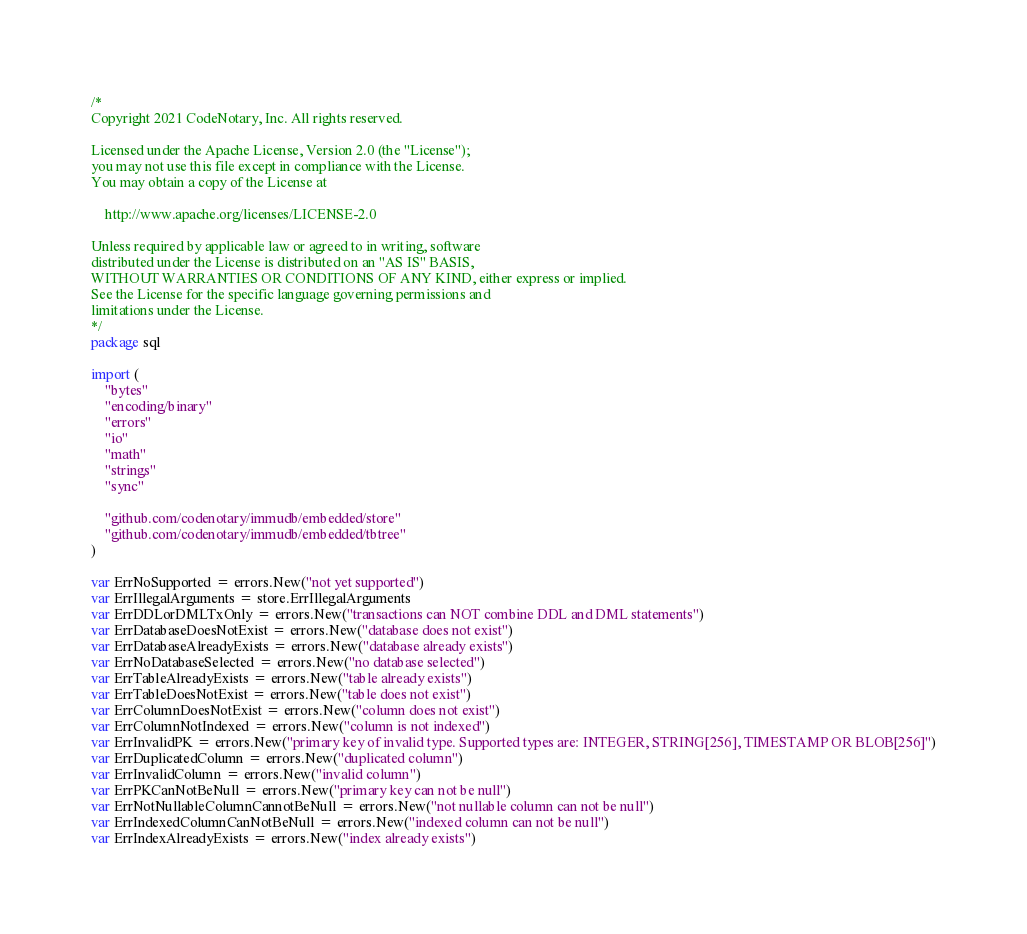<code> <loc_0><loc_0><loc_500><loc_500><_Go_>/*
Copyright 2021 CodeNotary, Inc. All rights reserved.

Licensed under the Apache License, Version 2.0 (the "License");
you may not use this file except in compliance with the License.
You may obtain a copy of the License at

	http://www.apache.org/licenses/LICENSE-2.0

Unless required by applicable law or agreed to in writing, software
distributed under the License is distributed on an "AS IS" BASIS,
WITHOUT WARRANTIES OR CONDITIONS OF ANY KIND, either express or implied.
See the License for the specific language governing permissions and
limitations under the License.
*/
package sql

import (
	"bytes"
	"encoding/binary"
	"errors"
	"io"
	"math"
	"strings"
	"sync"

	"github.com/codenotary/immudb/embedded/store"
	"github.com/codenotary/immudb/embedded/tbtree"
)

var ErrNoSupported = errors.New("not yet supported")
var ErrIllegalArguments = store.ErrIllegalArguments
var ErrDDLorDMLTxOnly = errors.New("transactions can NOT combine DDL and DML statements")
var ErrDatabaseDoesNotExist = errors.New("database does not exist")
var ErrDatabaseAlreadyExists = errors.New("database already exists")
var ErrNoDatabaseSelected = errors.New("no database selected")
var ErrTableAlreadyExists = errors.New("table already exists")
var ErrTableDoesNotExist = errors.New("table does not exist")
var ErrColumnDoesNotExist = errors.New("column does not exist")
var ErrColumnNotIndexed = errors.New("column is not indexed")
var ErrInvalidPK = errors.New("primary key of invalid type. Supported types are: INTEGER, STRING[256], TIMESTAMP OR BLOB[256]")
var ErrDuplicatedColumn = errors.New("duplicated column")
var ErrInvalidColumn = errors.New("invalid column")
var ErrPKCanNotBeNull = errors.New("primary key can not be null")
var ErrNotNullableColumnCannotBeNull = errors.New("not nullable column can not be null")
var ErrIndexedColumnCanNotBeNull = errors.New("indexed column can not be null")
var ErrIndexAlreadyExists = errors.New("index already exists")</code> 